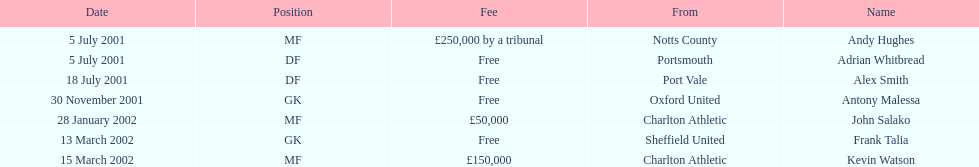Parse the table in full. {'header': ['Date', 'Position', 'Fee', 'From', 'Name'], 'rows': [['5 July 2001', 'MF', '£250,000 by a tribunal', 'Notts County', 'Andy Hughes'], ['5 July 2001', 'DF', 'Free', 'Portsmouth', 'Adrian Whitbread'], ['18 July 2001', 'DF', 'Free', 'Port Vale', 'Alex Smith'], ['30 November 2001', 'GK', 'Free', 'Oxford United', 'Antony Malessa'], ['28 January 2002', 'MF', '£50,000', 'Charlton Athletic', 'John Salako'], ['13 March 2002', 'GK', 'Free', 'Sheffield United', 'Frank Talia'], ['15 March 2002', 'MF', '£150,000', 'Charlton Athletic', 'Kevin Watson']]} Which individuals underwent a transfer following november 30, 2001? John Salako, Frank Talia, Kevin Watson. 